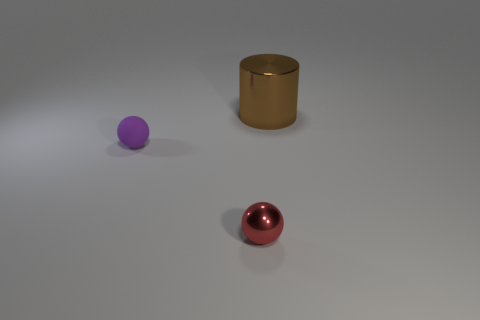Is there anything else that is the same size as the brown metal cylinder?
Provide a succinct answer. No. How big is the metal thing behind the metal object in front of the object that is behind the purple sphere?
Offer a very short reply. Large. What is the tiny purple ball made of?
Your answer should be very brief. Rubber. Does the red ball have the same material as the object behind the tiny purple matte ball?
Provide a succinct answer. Yes. Is there anything else that is the same color as the small shiny object?
Keep it short and to the point. No. Is there a purple thing that is behind the metal thing that is behind the thing that is on the left side of the tiny red ball?
Your answer should be compact. No. The metallic cylinder has what color?
Your response must be concise. Brown. There is a small red object; are there any metallic objects in front of it?
Keep it short and to the point. No. Is the shape of the small purple rubber object the same as the metal thing right of the tiny metal thing?
Give a very brief answer. No. How many other objects are there of the same material as the tiny purple sphere?
Keep it short and to the point. 0. 